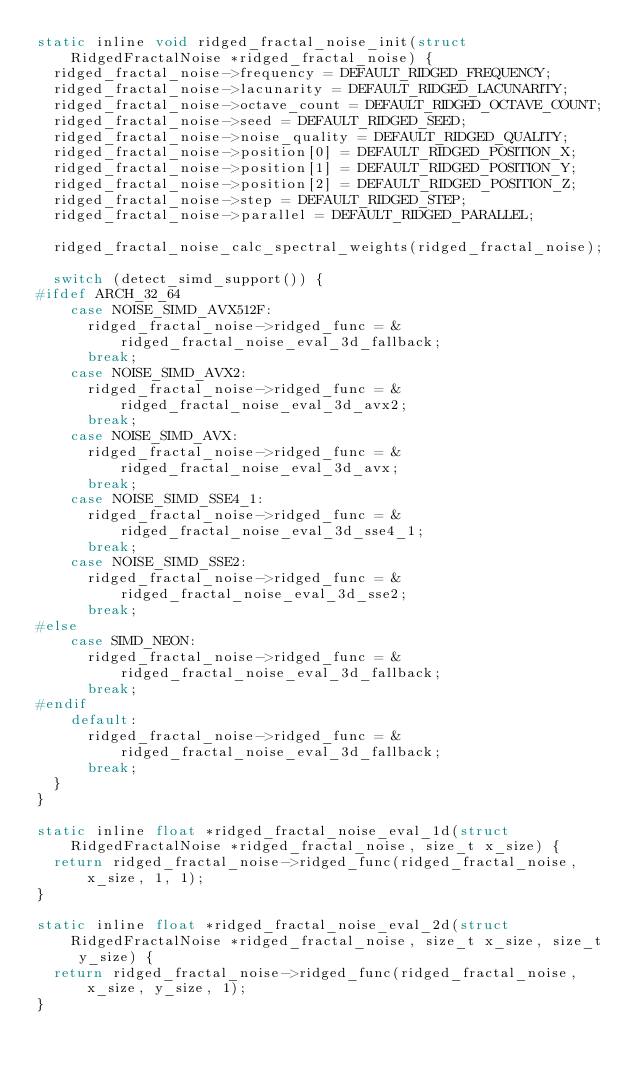<code> <loc_0><loc_0><loc_500><loc_500><_C_>static inline void ridged_fractal_noise_init(struct RidgedFractalNoise *ridged_fractal_noise) {
  ridged_fractal_noise->frequency = DEFAULT_RIDGED_FREQUENCY;
  ridged_fractal_noise->lacunarity = DEFAULT_RIDGED_LACUNARITY;
  ridged_fractal_noise->octave_count = DEFAULT_RIDGED_OCTAVE_COUNT;
  ridged_fractal_noise->seed = DEFAULT_RIDGED_SEED;
  ridged_fractal_noise->noise_quality = DEFAULT_RIDGED_QUALITY;
  ridged_fractal_noise->position[0] = DEFAULT_RIDGED_POSITION_X;
  ridged_fractal_noise->position[1] = DEFAULT_RIDGED_POSITION_Y;
  ridged_fractal_noise->position[2] = DEFAULT_RIDGED_POSITION_Z;
  ridged_fractal_noise->step = DEFAULT_RIDGED_STEP;
  ridged_fractal_noise->parallel = DEFAULT_RIDGED_PARALLEL;

  ridged_fractal_noise_calc_spectral_weights(ridged_fractal_noise);

  switch (detect_simd_support()) {
#ifdef ARCH_32_64
    case NOISE_SIMD_AVX512F:
      ridged_fractal_noise->ridged_func = &ridged_fractal_noise_eval_3d_fallback;
      break;
    case NOISE_SIMD_AVX2:
      ridged_fractal_noise->ridged_func = &ridged_fractal_noise_eval_3d_avx2;
      break;
    case NOISE_SIMD_AVX:
      ridged_fractal_noise->ridged_func = &ridged_fractal_noise_eval_3d_avx;
      break;
    case NOISE_SIMD_SSE4_1:
      ridged_fractal_noise->ridged_func = &ridged_fractal_noise_eval_3d_sse4_1;
      break;
    case NOISE_SIMD_SSE2:
      ridged_fractal_noise->ridged_func = &ridged_fractal_noise_eval_3d_sse2;
      break;
#else
    case SIMD_NEON:
      ridged_fractal_noise->ridged_func = &ridged_fractal_noise_eval_3d_fallback;
      break;
#endif
    default:
      ridged_fractal_noise->ridged_func = &ridged_fractal_noise_eval_3d_fallback;
      break;
  }
}

static inline float *ridged_fractal_noise_eval_1d(struct RidgedFractalNoise *ridged_fractal_noise, size_t x_size) {
  return ridged_fractal_noise->ridged_func(ridged_fractal_noise, x_size, 1, 1);
}

static inline float *ridged_fractal_noise_eval_2d(struct RidgedFractalNoise *ridged_fractal_noise, size_t x_size, size_t y_size) {
  return ridged_fractal_noise->ridged_func(ridged_fractal_noise, x_size, y_size, 1);
}
</code> 